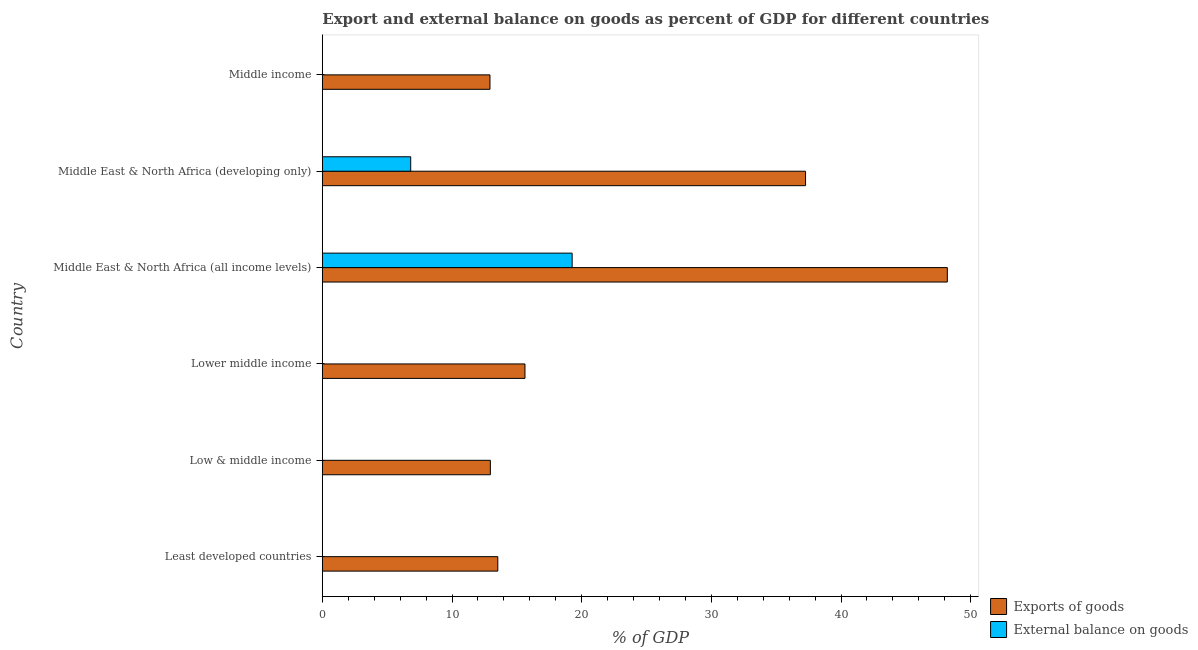How many bars are there on the 1st tick from the top?
Your answer should be compact. 1. How many bars are there on the 5th tick from the bottom?
Your answer should be very brief. 2. What is the label of the 2nd group of bars from the top?
Give a very brief answer. Middle East & North Africa (developing only). Across all countries, what is the maximum external balance on goods as percentage of gdp?
Give a very brief answer. 19.27. Across all countries, what is the minimum export of goods as percentage of gdp?
Make the answer very short. 12.93. In which country was the export of goods as percentage of gdp maximum?
Your answer should be compact. Middle East & North Africa (all income levels). What is the total export of goods as percentage of gdp in the graph?
Give a very brief answer. 140.51. What is the difference between the export of goods as percentage of gdp in Middle East & North Africa (developing only) and that in Middle income?
Offer a terse response. 24.34. What is the difference between the export of goods as percentage of gdp in Least developed countries and the external balance on goods as percentage of gdp in Middle East & North Africa (all income levels)?
Keep it short and to the point. -5.73. What is the average external balance on goods as percentage of gdp per country?
Your response must be concise. 4.35. What is the difference between the external balance on goods as percentage of gdp and export of goods as percentage of gdp in Middle East & North Africa (developing only)?
Your answer should be very brief. -30.45. What is the ratio of the external balance on goods as percentage of gdp in Middle East & North Africa (all income levels) to that in Middle East & North Africa (developing only)?
Offer a terse response. 2.83. Is the export of goods as percentage of gdp in Low & middle income less than that in Middle East & North Africa (developing only)?
Your response must be concise. Yes. What is the difference between the highest and the second highest export of goods as percentage of gdp?
Provide a succinct answer. 10.93. What is the difference between the highest and the lowest external balance on goods as percentage of gdp?
Offer a very short reply. 19.27. Is the sum of the export of goods as percentage of gdp in Lower middle income and Middle East & North Africa (developing only) greater than the maximum external balance on goods as percentage of gdp across all countries?
Ensure brevity in your answer.  Yes. How many bars are there?
Your answer should be very brief. 8. Are all the bars in the graph horizontal?
Give a very brief answer. Yes. How many countries are there in the graph?
Ensure brevity in your answer.  6. What is the difference between two consecutive major ticks on the X-axis?
Provide a short and direct response. 10. Does the graph contain any zero values?
Offer a very short reply. Yes. Does the graph contain grids?
Provide a short and direct response. No. Where does the legend appear in the graph?
Ensure brevity in your answer.  Bottom right. How many legend labels are there?
Your answer should be very brief. 2. What is the title of the graph?
Your response must be concise. Export and external balance on goods as percent of GDP for different countries. Does "Rural" appear as one of the legend labels in the graph?
Your response must be concise. No. What is the label or title of the X-axis?
Offer a terse response. % of GDP. What is the label or title of the Y-axis?
Provide a short and direct response. Country. What is the % of GDP of Exports of goods in Least developed countries?
Give a very brief answer. 13.53. What is the % of GDP of Exports of goods in Low & middle income?
Provide a succinct answer. 12.96. What is the % of GDP of Exports of goods in Lower middle income?
Provide a short and direct response. 15.63. What is the % of GDP in External balance on goods in Lower middle income?
Make the answer very short. 0. What is the % of GDP of Exports of goods in Middle East & North Africa (all income levels)?
Offer a terse response. 48.2. What is the % of GDP of External balance on goods in Middle East & North Africa (all income levels)?
Give a very brief answer. 19.27. What is the % of GDP of Exports of goods in Middle East & North Africa (developing only)?
Give a very brief answer. 37.27. What is the % of GDP of External balance on goods in Middle East & North Africa (developing only)?
Provide a succinct answer. 6.82. What is the % of GDP of Exports of goods in Middle income?
Offer a terse response. 12.93. Across all countries, what is the maximum % of GDP in Exports of goods?
Provide a succinct answer. 48.2. Across all countries, what is the maximum % of GDP in External balance on goods?
Your response must be concise. 19.27. Across all countries, what is the minimum % of GDP of Exports of goods?
Your answer should be compact. 12.93. Across all countries, what is the minimum % of GDP of External balance on goods?
Your answer should be compact. 0. What is the total % of GDP in Exports of goods in the graph?
Make the answer very short. 140.51. What is the total % of GDP in External balance on goods in the graph?
Provide a succinct answer. 26.08. What is the difference between the % of GDP in Exports of goods in Least developed countries and that in Low & middle income?
Offer a very short reply. 0.57. What is the difference between the % of GDP of Exports of goods in Least developed countries and that in Lower middle income?
Make the answer very short. -2.09. What is the difference between the % of GDP in Exports of goods in Least developed countries and that in Middle East & North Africa (all income levels)?
Make the answer very short. -34.67. What is the difference between the % of GDP of Exports of goods in Least developed countries and that in Middle East & North Africa (developing only)?
Your answer should be very brief. -23.73. What is the difference between the % of GDP in Exports of goods in Least developed countries and that in Middle income?
Your answer should be very brief. 0.6. What is the difference between the % of GDP in Exports of goods in Low & middle income and that in Lower middle income?
Your answer should be compact. -2.67. What is the difference between the % of GDP in Exports of goods in Low & middle income and that in Middle East & North Africa (all income levels)?
Your response must be concise. -35.24. What is the difference between the % of GDP of Exports of goods in Low & middle income and that in Middle East & North Africa (developing only)?
Give a very brief answer. -24.31. What is the difference between the % of GDP of Exports of goods in Low & middle income and that in Middle income?
Ensure brevity in your answer.  0.03. What is the difference between the % of GDP in Exports of goods in Lower middle income and that in Middle East & North Africa (all income levels)?
Make the answer very short. -32.57. What is the difference between the % of GDP in Exports of goods in Lower middle income and that in Middle East & North Africa (developing only)?
Offer a terse response. -21.64. What is the difference between the % of GDP of Exports of goods in Lower middle income and that in Middle income?
Ensure brevity in your answer.  2.7. What is the difference between the % of GDP in Exports of goods in Middle East & North Africa (all income levels) and that in Middle East & North Africa (developing only)?
Offer a very short reply. 10.93. What is the difference between the % of GDP in External balance on goods in Middle East & North Africa (all income levels) and that in Middle East & North Africa (developing only)?
Give a very brief answer. 12.45. What is the difference between the % of GDP of Exports of goods in Middle East & North Africa (all income levels) and that in Middle income?
Provide a succinct answer. 35.27. What is the difference between the % of GDP of Exports of goods in Middle East & North Africa (developing only) and that in Middle income?
Keep it short and to the point. 24.34. What is the difference between the % of GDP of Exports of goods in Least developed countries and the % of GDP of External balance on goods in Middle East & North Africa (all income levels)?
Make the answer very short. -5.73. What is the difference between the % of GDP in Exports of goods in Least developed countries and the % of GDP in External balance on goods in Middle East & North Africa (developing only)?
Offer a very short reply. 6.72. What is the difference between the % of GDP of Exports of goods in Low & middle income and the % of GDP of External balance on goods in Middle East & North Africa (all income levels)?
Your answer should be compact. -6.31. What is the difference between the % of GDP in Exports of goods in Low & middle income and the % of GDP in External balance on goods in Middle East & North Africa (developing only)?
Give a very brief answer. 6.14. What is the difference between the % of GDP in Exports of goods in Lower middle income and the % of GDP in External balance on goods in Middle East & North Africa (all income levels)?
Make the answer very short. -3.64. What is the difference between the % of GDP in Exports of goods in Lower middle income and the % of GDP in External balance on goods in Middle East & North Africa (developing only)?
Keep it short and to the point. 8.81. What is the difference between the % of GDP of Exports of goods in Middle East & North Africa (all income levels) and the % of GDP of External balance on goods in Middle East & North Africa (developing only)?
Offer a terse response. 41.38. What is the average % of GDP of Exports of goods per country?
Keep it short and to the point. 23.42. What is the average % of GDP in External balance on goods per country?
Keep it short and to the point. 4.35. What is the difference between the % of GDP in Exports of goods and % of GDP in External balance on goods in Middle East & North Africa (all income levels)?
Your answer should be very brief. 28.93. What is the difference between the % of GDP in Exports of goods and % of GDP in External balance on goods in Middle East & North Africa (developing only)?
Offer a terse response. 30.45. What is the ratio of the % of GDP of Exports of goods in Least developed countries to that in Low & middle income?
Keep it short and to the point. 1.04. What is the ratio of the % of GDP in Exports of goods in Least developed countries to that in Lower middle income?
Give a very brief answer. 0.87. What is the ratio of the % of GDP of Exports of goods in Least developed countries to that in Middle East & North Africa (all income levels)?
Your response must be concise. 0.28. What is the ratio of the % of GDP in Exports of goods in Least developed countries to that in Middle East & North Africa (developing only)?
Your answer should be very brief. 0.36. What is the ratio of the % of GDP in Exports of goods in Least developed countries to that in Middle income?
Ensure brevity in your answer.  1.05. What is the ratio of the % of GDP of Exports of goods in Low & middle income to that in Lower middle income?
Ensure brevity in your answer.  0.83. What is the ratio of the % of GDP in Exports of goods in Low & middle income to that in Middle East & North Africa (all income levels)?
Provide a succinct answer. 0.27. What is the ratio of the % of GDP in Exports of goods in Low & middle income to that in Middle East & North Africa (developing only)?
Provide a succinct answer. 0.35. What is the ratio of the % of GDP of Exports of goods in Lower middle income to that in Middle East & North Africa (all income levels)?
Provide a short and direct response. 0.32. What is the ratio of the % of GDP of Exports of goods in Lower middle income to that in Middle East & North Africa (developing only)?
Offer a terse response. 0.42. What is the ratio of the % of GDP of Exports of goods in Lower middle income to that in Middle income?
Give a very brief answer. 1.21. What is the ratio of the % of GDP of Exports of goods in Middle East & North Africa (all income levels) to that in Middle East & North Africa (developing only)?
Offer a very short reply. 1.29. What is the ratio of the % of GDP of External balance on goods in Middle East & North Africa (all income levels) to that in Middle East & North Africa (developing only)?
Offer a terse response. 2.83. What is the ratio of the % of GDP in Exports of goods in Middle East & North Africa (all income levels) to that in Middle income?
Your answer should be very brief. 3.73. What is the ratio of the % of GDP in Exports of goods in Middle East & North Africa (developing only) to that in Middle income?
Your answer should be very brief. 2.88. What is the difference between the highest and the second highest % of GDP in Exports of goods?
Give a very brief answer. 10.93. What is the difference between the highest and the lowest % of GDP of Exports of goods?
Ensure brevity in your answer.  35.27. What is the difference between the highest and the lowest % of GDP in External balance on goods?
Give a very brief answer. 19.27. 